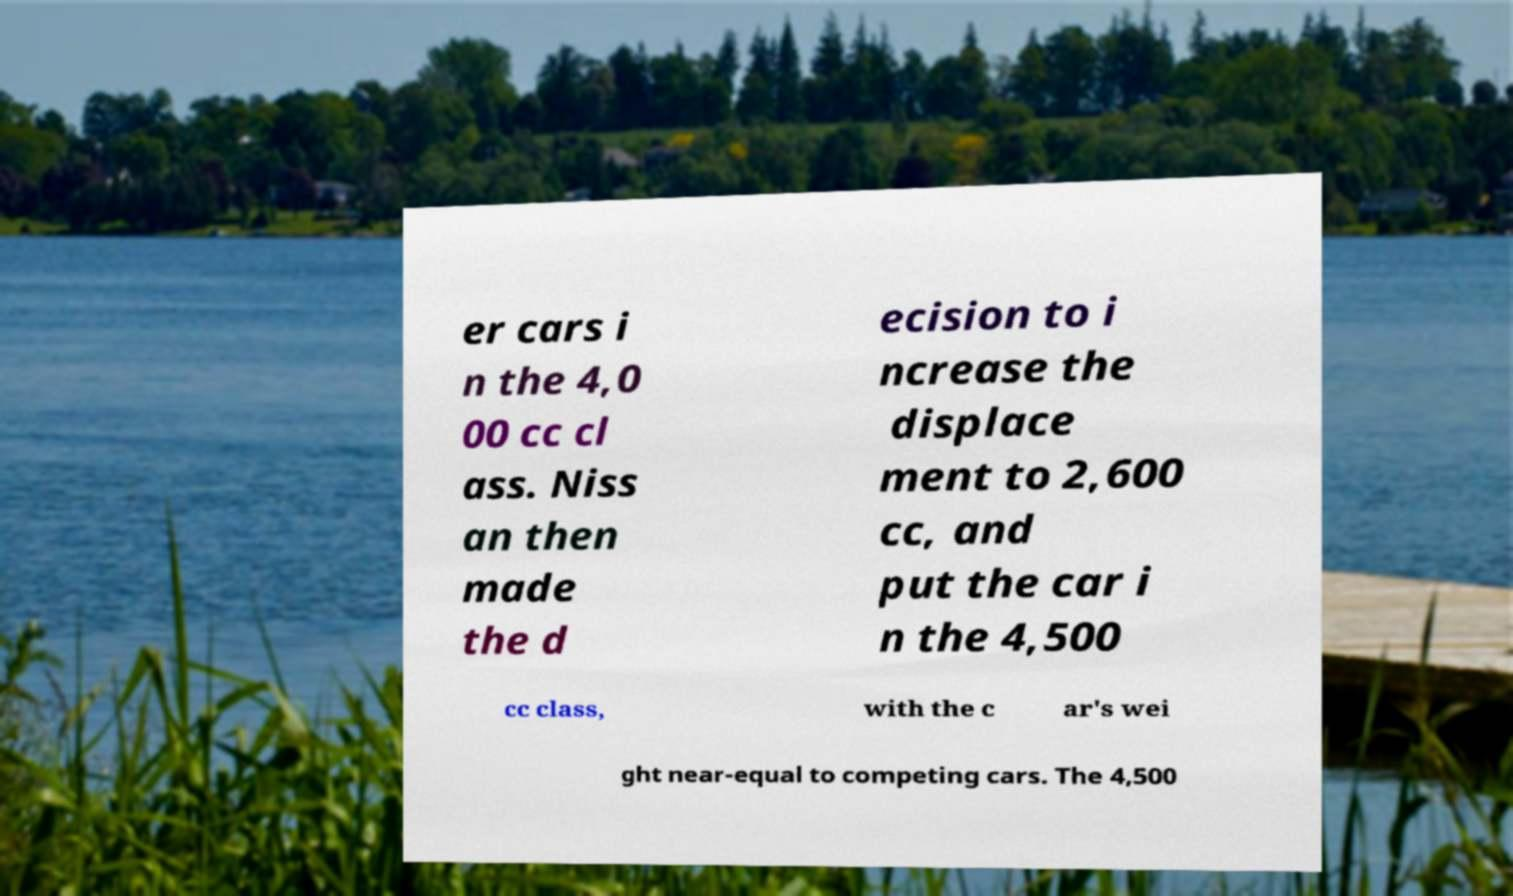Could you assist in decoding the text presented in this image and type it out clearly? er cars i n the 4,0 00 cc cl ass. Niss an then made the d ecision to i ncrease the displace ment to 2,600 cc, and put the car i n the 4,500 cc class, with the c ar's wei ght near-equal to competing cars. The 4,500 